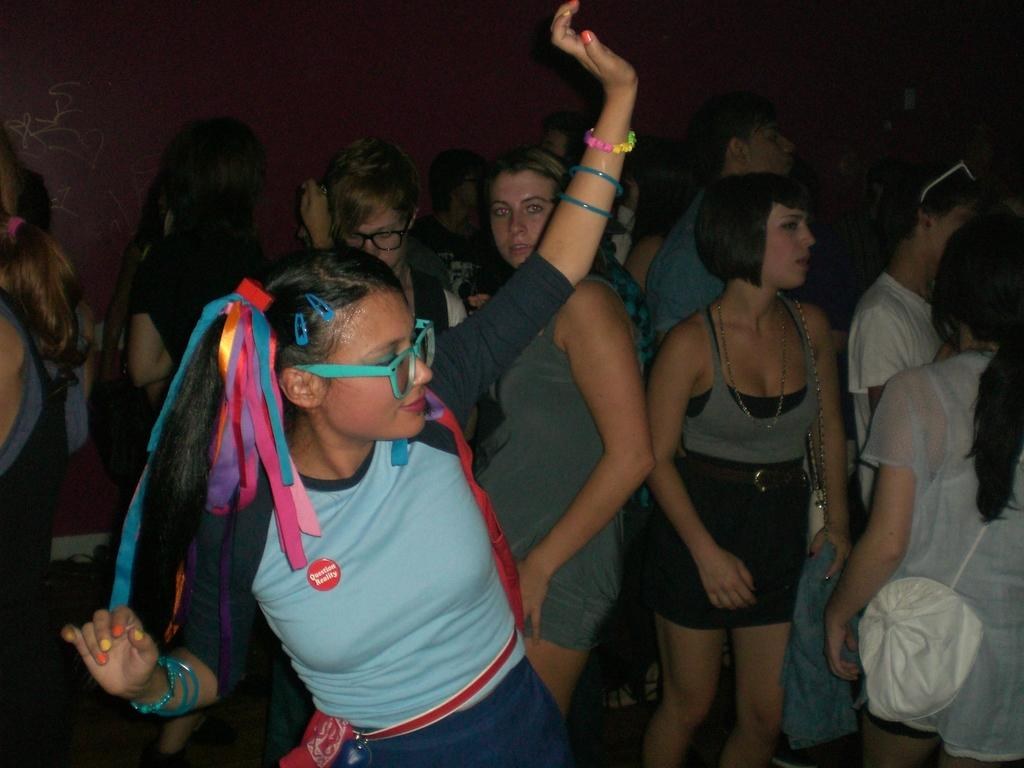How many people are in the image? There is a group of people in the image, but the exact number is not specified. What is the background of the image? The group of people is in front of a wall. What verse is being recited by the group in the image? There is no indication in the image that the group is reciting a verse or any form of text. 